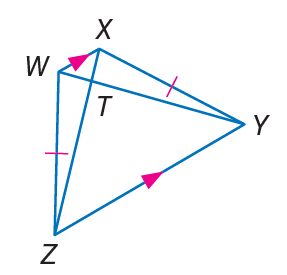Answer the mathemtical geometry problem and directly provide the correct option letter.
Question: Find W T, if Z X = 20 and T Y = 15.
Choices: A: 5 B: 15 C: 20 D: 35 A 